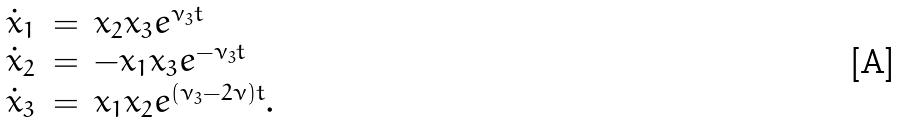<formula> <loc_0><loc_0><loc_500><loc_500>\begin{array} { l l l } \dot { x } _ { 1 } & = & x _ { 2 } x _ { 3 } e ^ { \nu _ { 3 } t } \\ \dot { x } _ { 2 } & = & - x _ { 1 } x _ { 3 } e ^ { - \nu _ { 3 } t } \\ \dot { x } _ { 3 } & = & x _ { 1 } x _ { 2 } e ^ { ( \nu _ { 3 } - 2 \nu ) t } . \\ \end{array}</formula> 